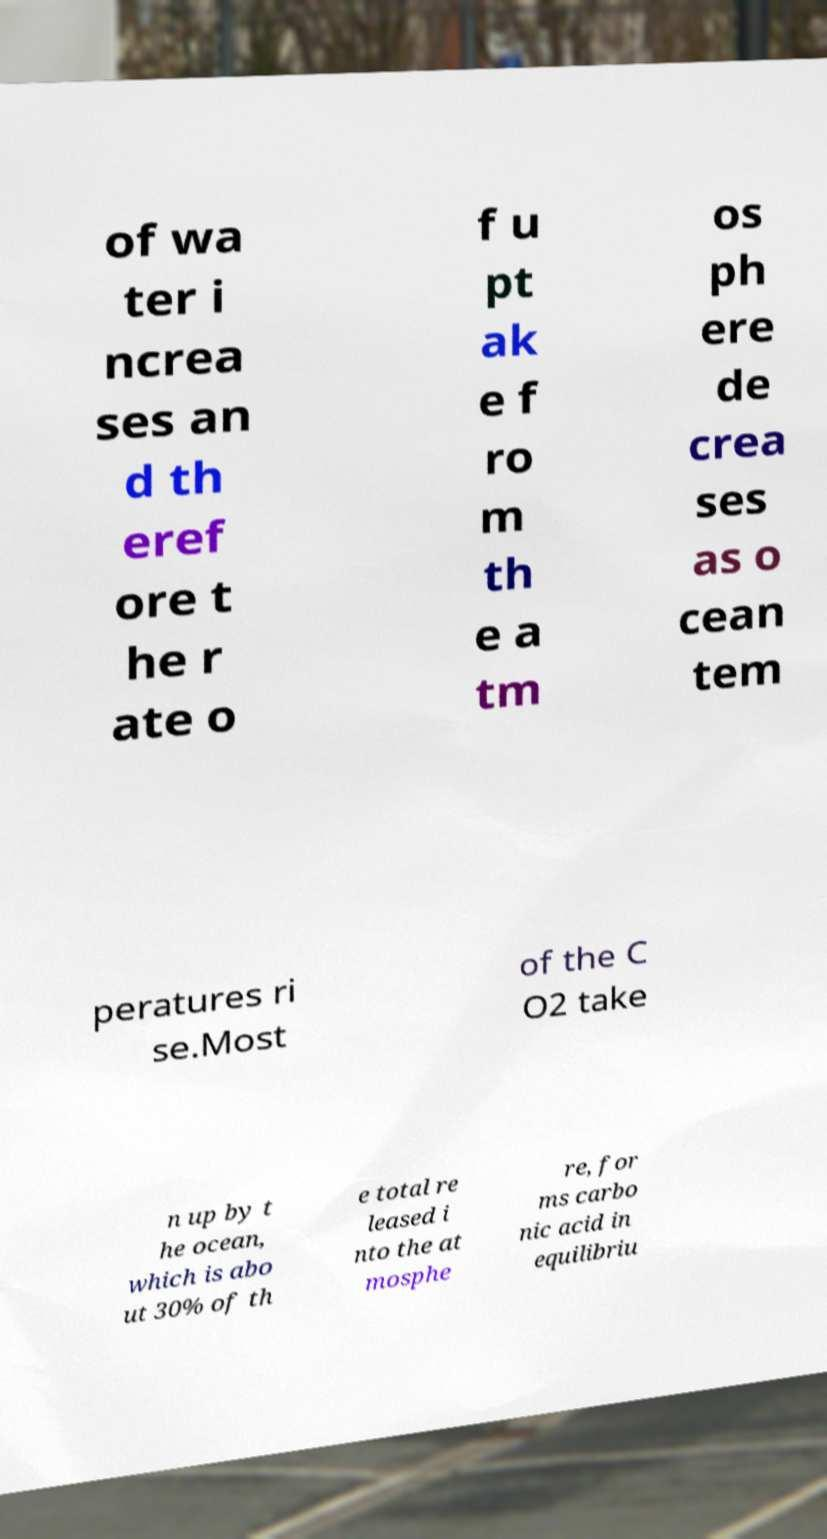Can you accurately transcribe the text from the provided image for me? of wa ter i ncrea ses an d th eref ore t he r ate o f u pt ak e f ro m th e a tm os ph ere de crea ses as o cean tem peratures ri se.Most of the C O2 take n up by t he ocean, which is abo ut 30% of th e total re leased i nto the at mosphe re, for ms carbo nic acid in equilibriu 